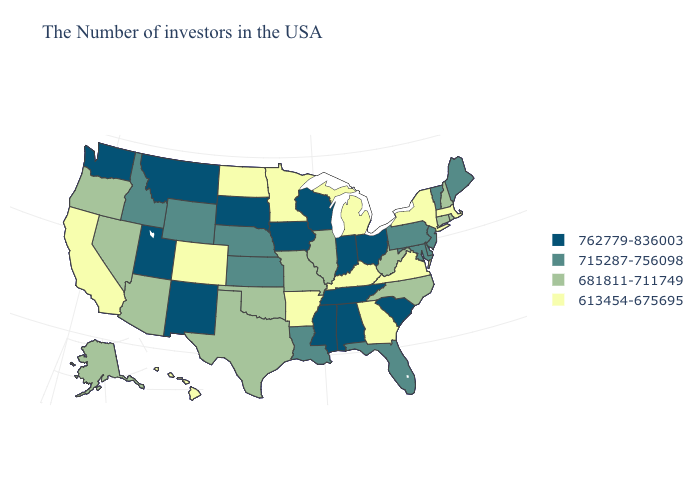What is the value of Alabama?
Be succinct. 762779-836003. Is the legend a continuous bar?
Answer briefly. No. Does Virginia have the highest value in the USA?
Answer briefly. No. What is the lowest value in the Northeast?
Concise answer only. 613454-675695. What is the lowest value in the USA?
Write a very short answer. 613454-675695. Does New Mexico have the highest value in the USA?
Write a very short answer. Yes. Which states have the lowest value in the USA?
Short answer required. Massachusetts, New York, Virginia, Georgia, Michigan, Kentucky, Arkansas, Minnesota, North Dakota, Colorado, California, Hawaii. What is the value of Arkansas?
Be succinct. 613454-675695. Does Nebraska have the highest value in the MidWest?
Short answer required. No. Name the states that have a value in the range 762779-836003?
Short answer required. South Carolina, Ohio, Indiana, Alabama, Tennessee, Wisconsin, Mississippi, Iowa, South Dakota, New Mexico, Utah, Montana, Washington. Name the states that have a value in the range 613454-675695?
Short answer required. Massachusetts, New York, Virginia, Georgia, Michigan, Kentucky, Arkansas, Minnesota, North Dakota, Colorado, California, Hawaii. Does the map have missing data?
Keep it brief. No. Name the states that have a value in the range 762779-836003?
Be succinct. South Carolina, Ohio, Indiana, Alabama, Tennessee, Wisconsin, Mississippi, Iowa, South Dakota, New Mexico, Utah, Montana, Washington. Does the first symbol in the legend represent the smallest category?
Be succinct. No. Name the states that have a value in the range 762779-836003?
Quick response, please. South Carolina, Ohio, Indiana, Alabama, Tennessee, Wisconsin, Mississippi, Iowa, South Dakota, New Mexico, Utah, Montana, Washington. 